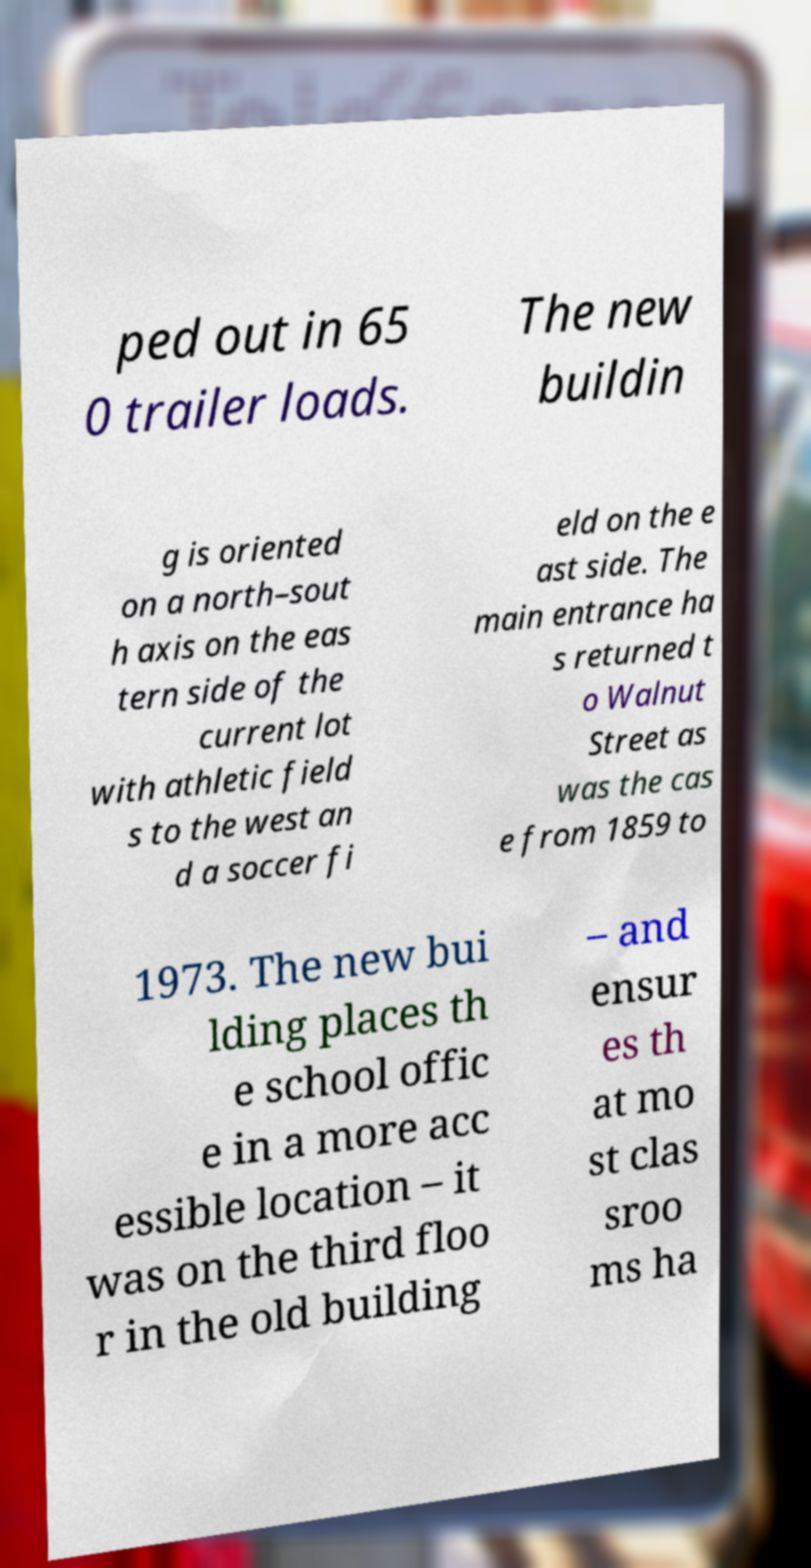For documentation purposes, I need the text within this image transcribed. Could you provide that? ped out in 65 0 trailer loads. The new buildin g is oriented on a north–sout h axis on the eas tern side of the current lot with athletic field s to the west an d a soccer fi eld on the e ast side. The main entrance ha s returned t o Walnut Street as was the cas e from 1859 to 1973. The new bui lding places th e school offic e in a more acc essible location – it was on the third floo r in the old building – and ensur es th at mo st clas sroo ms ha 